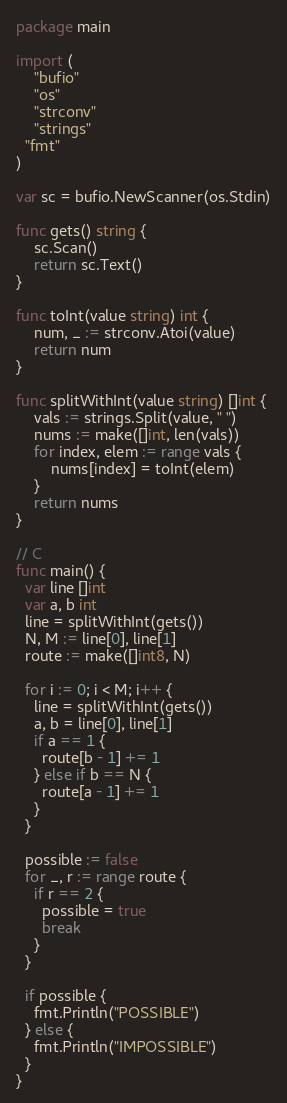<code> <loc_0><loc_0><loc_500><loc_500><_Go_>package main

import (
	"bufio"
	"os"
	"strconv"
	"strings"
  "fmt"
)

var sc = bufio.NewScanner(os.Stdin)

func gets() string {
	sc.Scan()
	return sc.Text()
}

func toInt(value string) int {
	num, _ := strconv.Atoi(value)
	return num
}

func splitWithInt(value string) []int {
	vals := strings.Split(value, " ")
	nums := make([]int, len(vals))
	for index, elem := range vals {
		nums[index] = toInt(elem)
	}
	return nums
}

// C
func main() {
  var line []int
  var a, b int
  line = splitWithInt(gets())
  N, M := line[0], line[1]
  route := make([]int8, N)

  for i := 0; i < M; i++ {
    line = splitWithInt(gets())
    a, b = line[0], line[1]
    if a == 1 {
      route[b - 1] += 1
    } else if b == N {
      route[a - 1] += 1
    }
  }

  possible := false
  for _, r := range route {
    if r == 2 {
      possible = true
      break
    }
  }

  if possible {
    fmt.Println("POSSIBLE")
  } else {
    fmt.Println("IMPOSSIBLE")
  }
}
</code> 